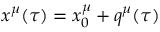Convert formula to latex. <formula><loc_0><loc_0><loc_500><loc_500>x ^ { \mu } ( \tau ) = x _ { 0 } ^ { \mu } + q ^ { \mu } ( \tau )</formula> 